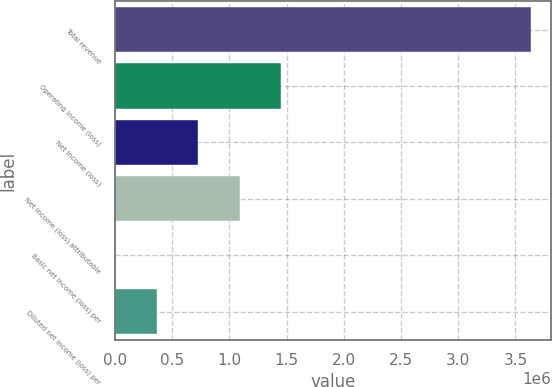Convert chart to OTSL. <chart><loc_0><loc_0><loc_500><loc_500><bar_chart><fcel>Total revenue<fcel>Operating income (loss)<fcel>Net income (loss)<fcel>Net income (loss) attributable<fcel>Basic net income (loss) per<fcel>Diluted net income (loss) per<nl><fcel>3.63145e+06<fcel>1.45258e+06<fcel>726291<fcel>1.08944e+06<fcel>0.7<fcel>363146<nl></chart> 